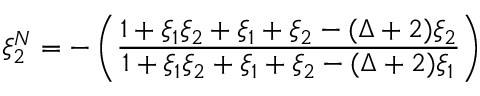<formula> <loc_0><loc_0><loc_500><loc_500>\xi _ { 2 } ^ { N } = - \left ( \frac { 1 + \xi _ { 1 } \xi _ { 2 } + \xi _ { 1 } + \xi _ { 2 } - ( \Delta + 2 ) \xi _ { 2 } } { 1 + \xi _ { 1 } \xi _ { 2 } + \xi _ { 1 } + \xi _ { 2 } - ( \Delta + 2 ) \xi _ { 1 } } \right )</formula> 